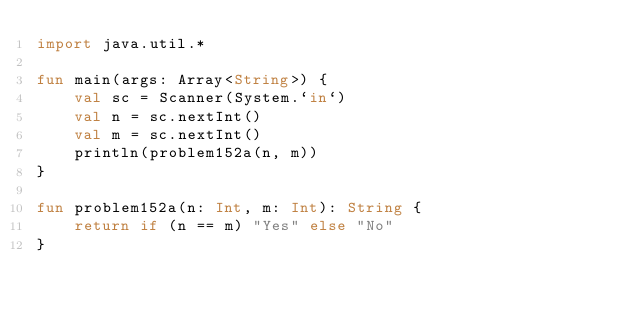<code> <loc_0><loc_0><loc_500><loc_500><_Kotlin_>import java.util.*

fun main(args: Array<String>) {
    val sc = Scanner(System.`in`)
    val n = sc.nextInt()
    val m = sc.nextInt()
    println(problem152a(n, m))
}

fun problem152a(n: Int, m: Int): String {
    return if (n == m) "Yes" else "No"
}</code> 